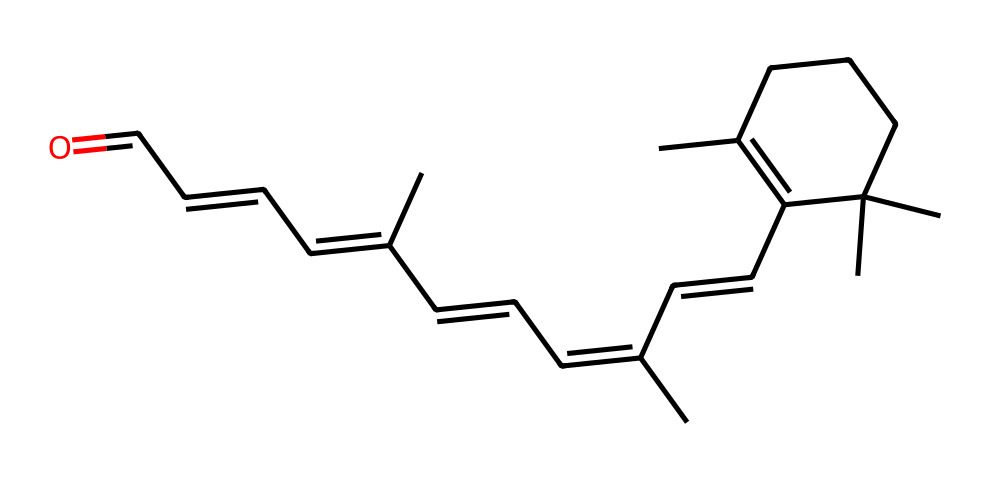What is the functional group present in this chemical? The chemical has a carbonyl group (C=O) at the end of its carbon chain, which is characteristic of aldehydes.
Answer: aldehyde How many double bonds are present in this structure? By analyzing the structure, we can count the visible double bonds between carbon atoms; there are six double bonds in total.
Answer: 6 What is the total number of carbon atoms in this molecule? The molecular structure shows a series of carbon atoms connected. Counting them yields a total of 20 carbon atoms.
Answer: 20 Which specific part of the molecule indicates that it is an aldehyde? The presence of the carbonyl group (C=O) at the terminal position of the carbon chain indicates that it is an aldehyde.
Answer: carbonyl group How many rings can be identified in the structure? The structure contains one ring, which can be identified by the cyclic arrangement of certain carbon atoms.
Answer: 1 What type of isomerism can this molecule exhibit? The multiple double bonds and the placement of functional groups allow this molecule to exhibit cis-trans isomerism specifically along the carbon backbone.
Answer: cis-trans isomerism 